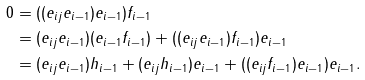Convert formula to latex. <formula><loc_0><loc_0><loc_500><loc_500>0 & = ( ( e _ { i j } e _ { i - 1 } ) e _ { i - 1 } ) f _ { i - 1 } \\ & = ( e _ { i j } e _ { i - 1 } ) ( e _ { i - 1 } f _ { i - 1 } ) + ( ( e _ { i j } e _ { i - 1 } ) f _ { i - 1 } ) e _ { i - 1 } \\ & = ( e _ { i j } e _ { i - 1 } ) h _ { i - 1 } + ( e _ { i j } h _ { i - 1 } ) e _ { i - 1 } + ( ( e _ { i j } f _ { i - 1 } ) e _ { i - 1 } ) e _ { i - 1 } .</formula> 